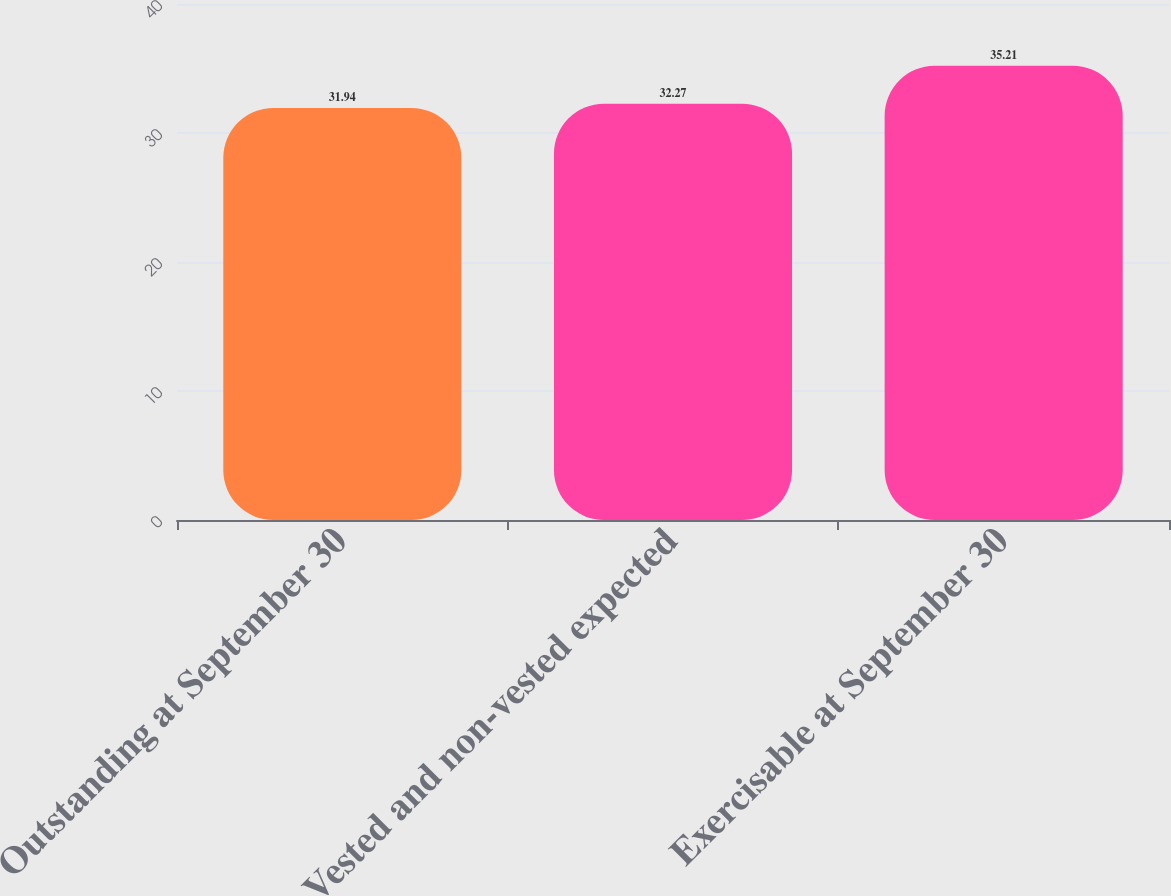Convert chart to OTSL. <chart><loc_0><loc_0><loc_500><loc_500><bar_chart><fcel>Outstanding at September 30<fcel>Vested and non-vested expected<fcel>Exercisable at September 30<nl><fcel>31.94<fcel>32.27<fcel>35.21<nl></chart> 